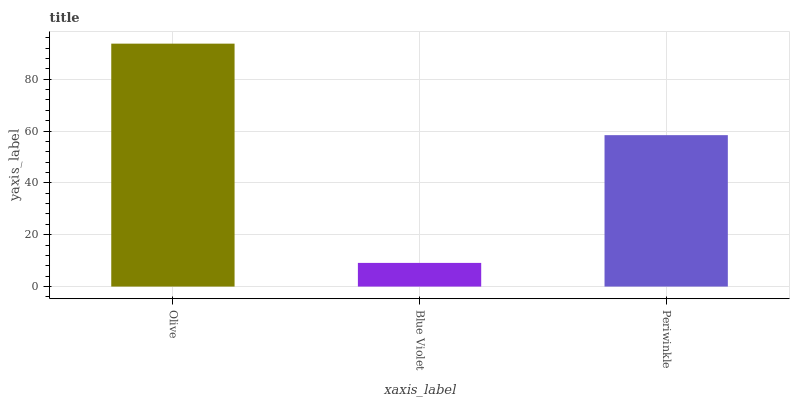Is Blue Violet the minimum?
Answer yes or no. Yes. Is Olive the maximum?
Answer yes or no. Yes. Is Periwinkle the minimum?
Answer yes or no. No. Is Periwinkle the maximum?
Answer yes or no. No. Is Periwinkle greater than Blue Violet?
Answer yes or no. Yes. Is Blue Violet less than Periwinkle?
Answer yes or no. Yes. Is Blue Violet greater than Periwinkle?
Answer yes or no. No. Is Periwinkle less than Blue Violet?
Answer yes or no. No. Is Periwinkle the high median?
Answer yes or no. Yes. Is Periwinkle the low median?
Answer yes or no. Yes. Is Olive the high median?
Answer yes or no. No. Is Olive the low median?
Answer yes or no. No. 